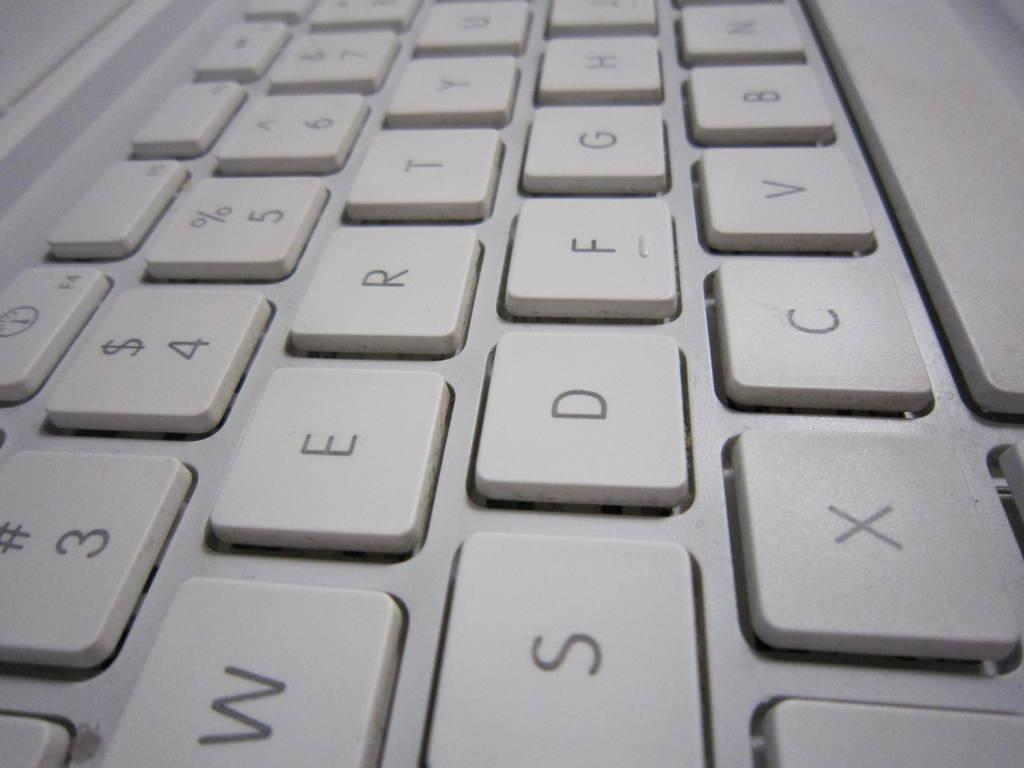<image>
Give a short and clear explanation of the subsequent image. The computer's keyboard is soft in tone and is also a "QWERTY" layout. 